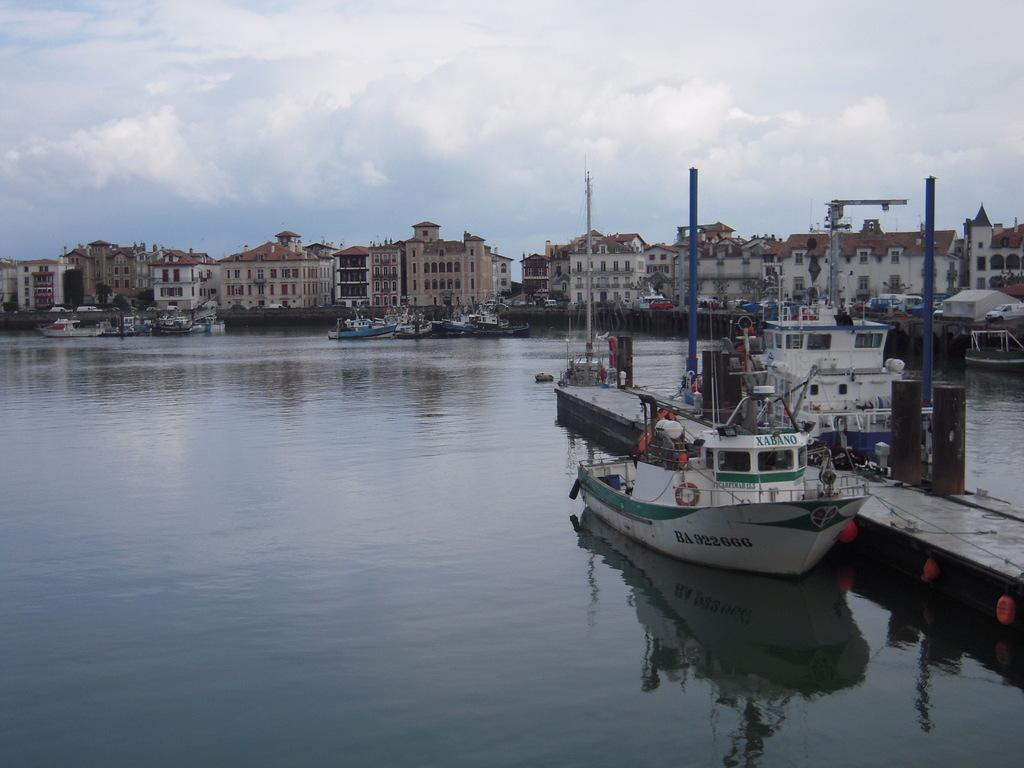<image>
Summarize the visual content of the image. a boat with the letters BA on the side of it 